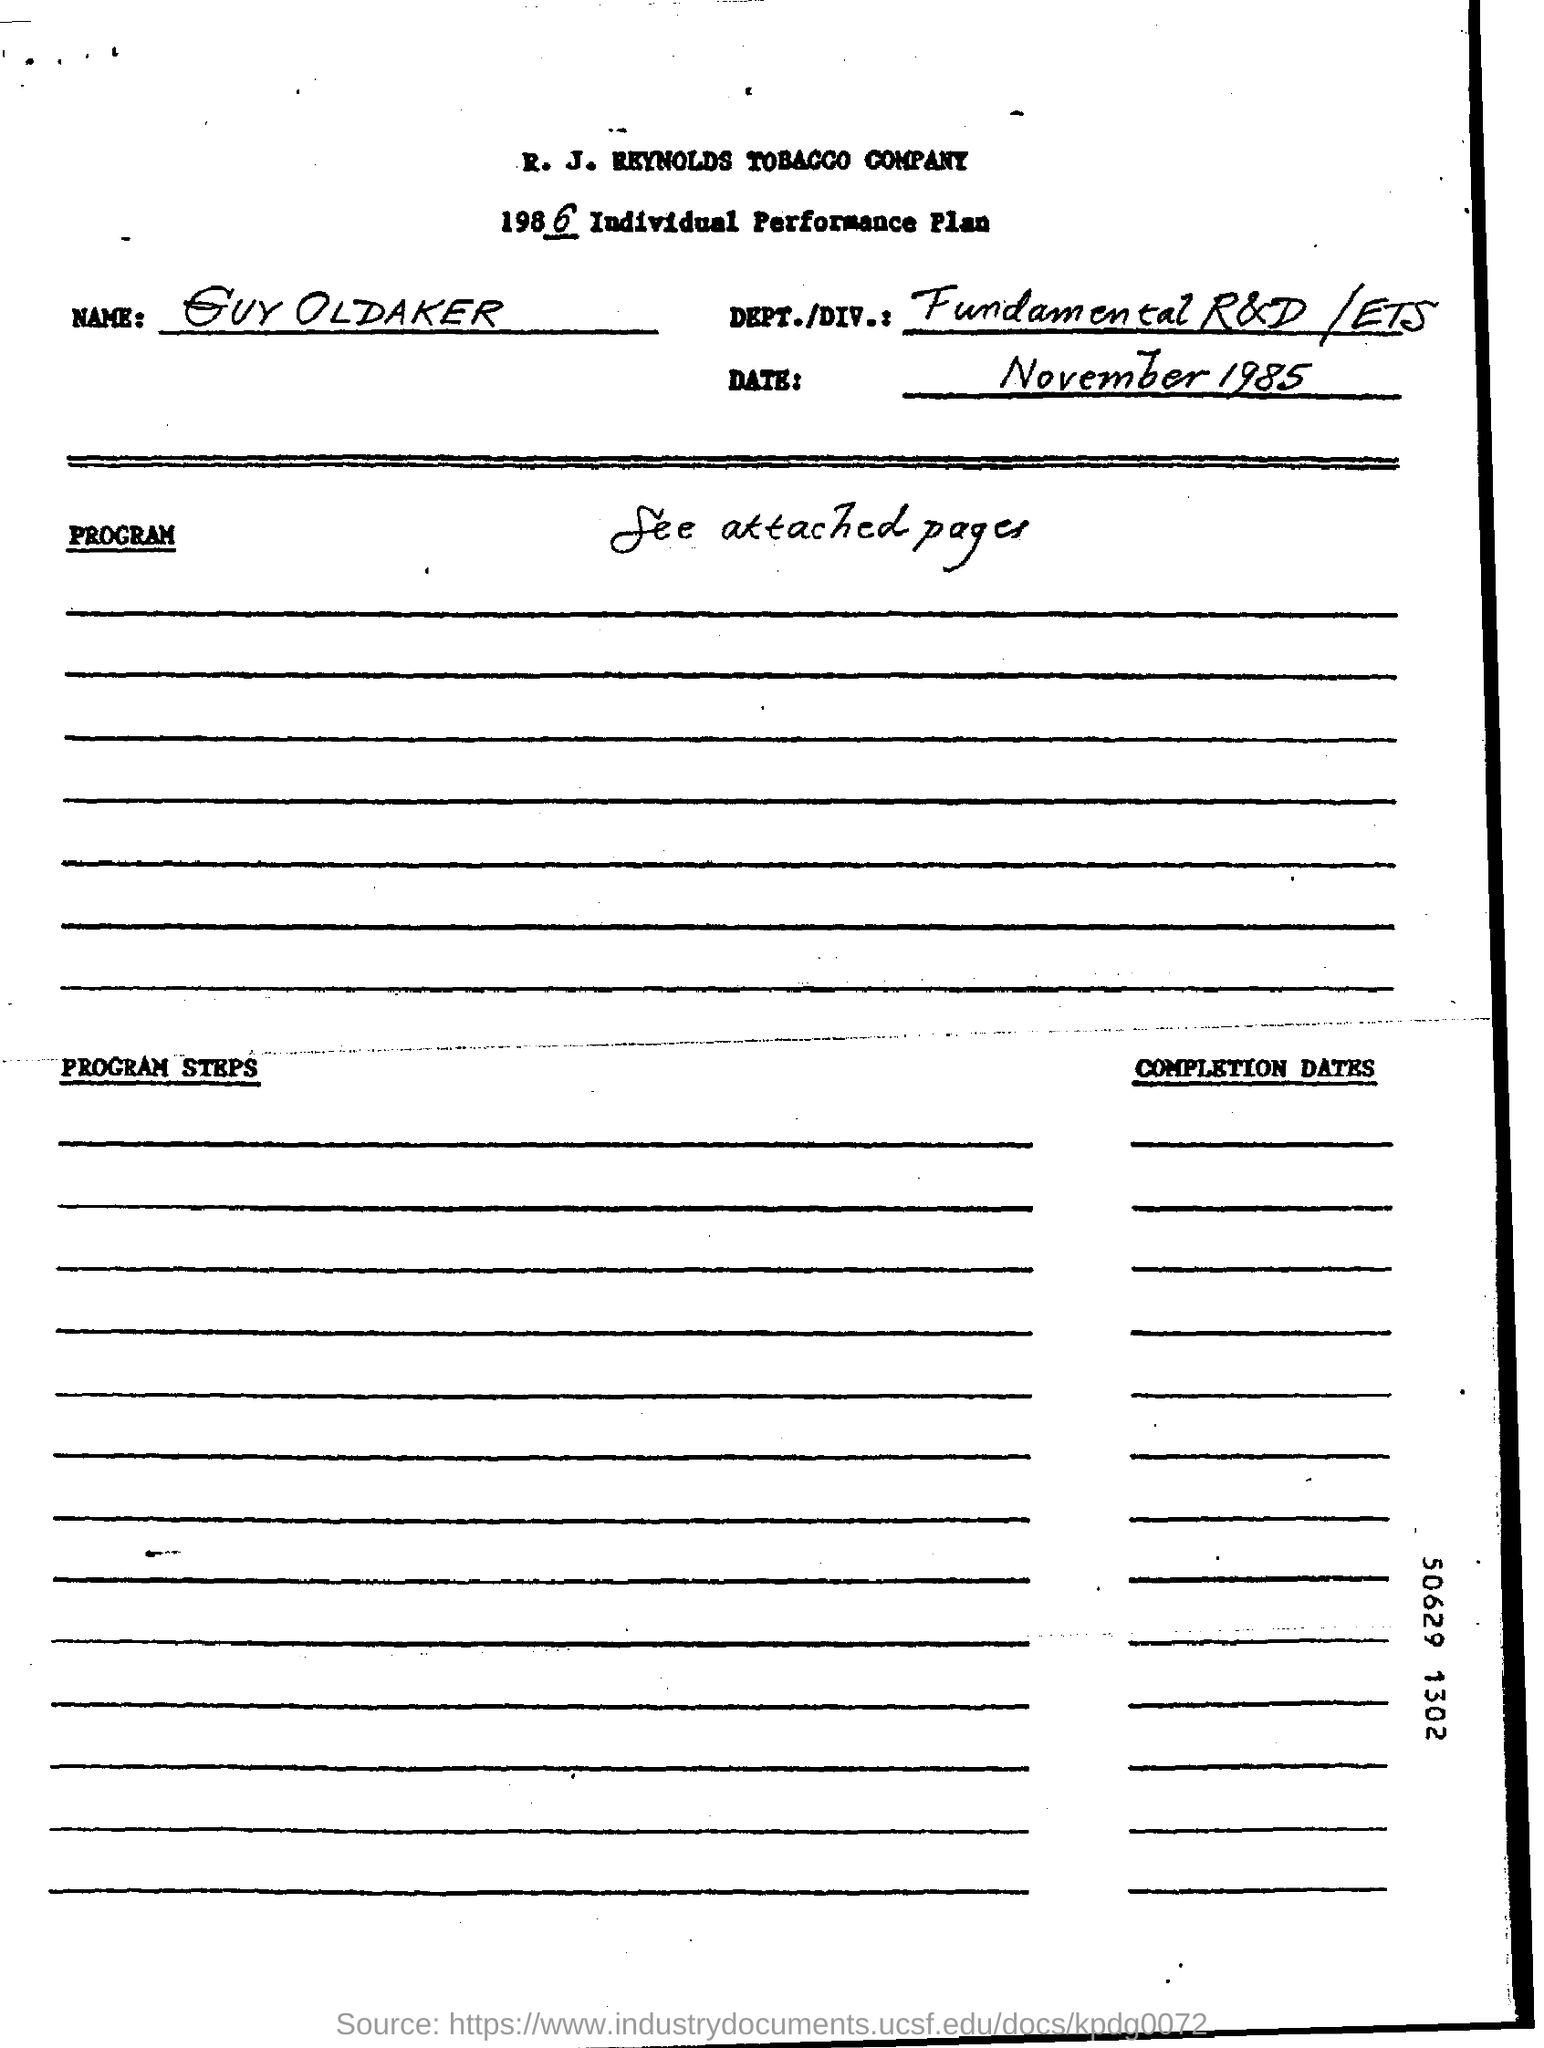What is the Company Name ?
Offer a terse response. R. J. REYNOLDS TOBACCO COMPANY. What is the date mentioned in the top of the document ?
Offer a very short reply. November 1985. What is written in the DEPT./DIV.: Field ?
Your answer should be compact. Fundamental R&D /ETS. 